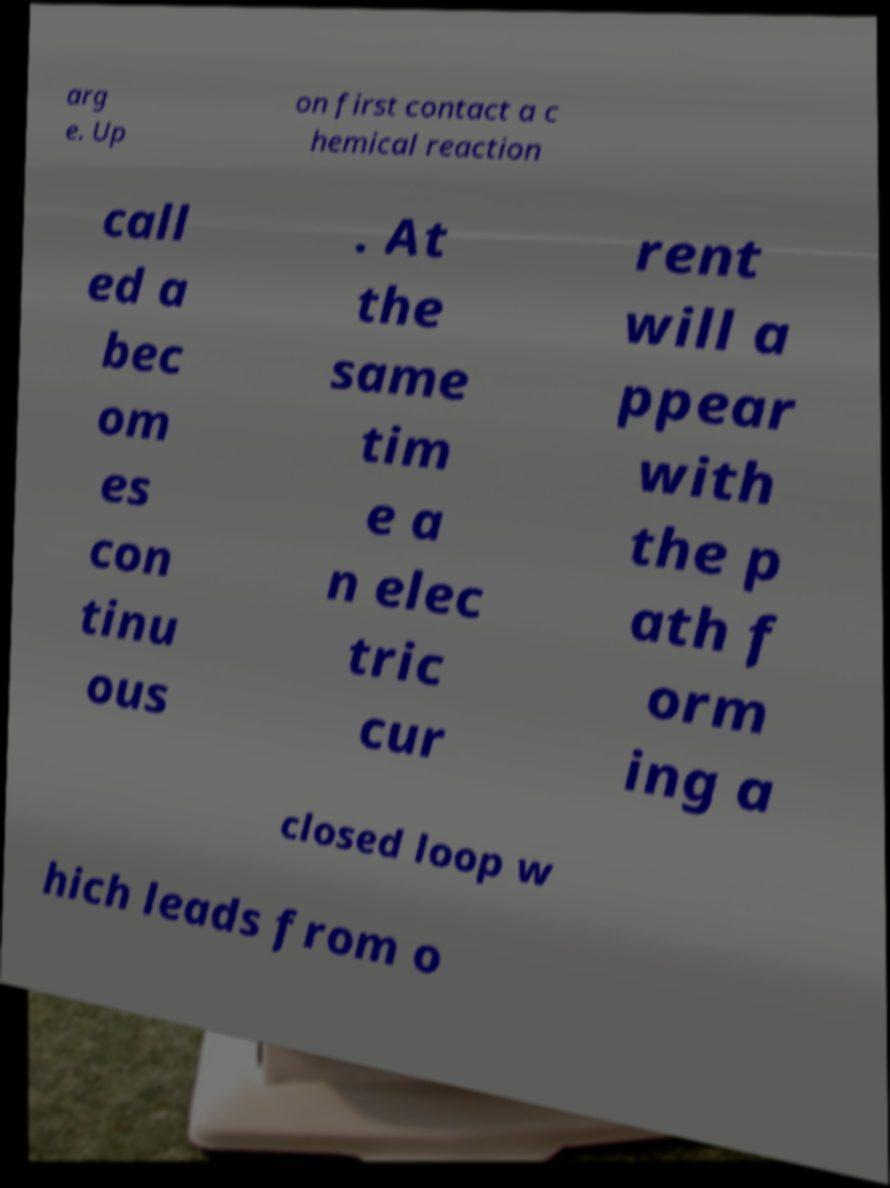What messages or text are displayed in this image? I need them in a readable, typed format. arg e. Up on first contact a c hemical reaction call ed a bec om es con tinu ous . At the same tim e a n elec tric cur rent will a ppear with the p ath f orm ing a closed loop w hich leads from o 